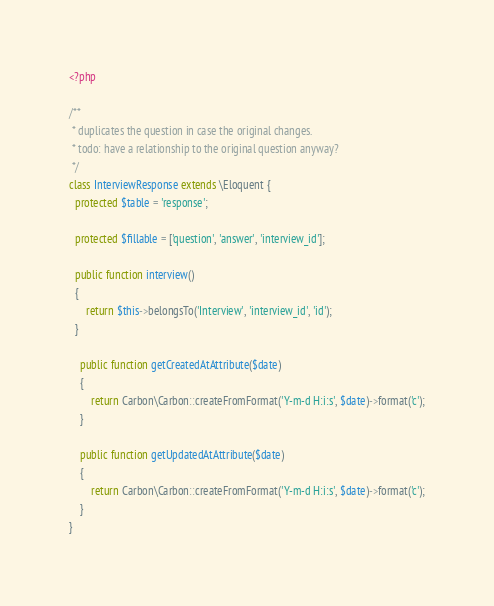Convert code to text. <code><loc_0><loc_0><loc_500><loc_500><_PHP_><?php

/**
 * duplicates the question in case the original changes.
 * todo: have a relationship to the original question anyway?
 */
class InterviewResponse extends \Eloquent {
  protected $table = 'response';

  protected $fillable = ['question', 'answer', 'interview_id'];

  public function interview()
  {
      return $this->belongsTo('Interview', 'interview_id', 'id');
  }

    public function getCreatedAtAttribute($date)
    {
        return Carbon\Carbon::createFromFormat('Y-m-d H:i:s', $date)->format('c');
    }

    public function getUpdatedAtAttribute($date)
    {
        return Carbon\Carbon::createFromFormat('Y-m-d H:i:s', $date)->format('c');
    }
}
</code> 